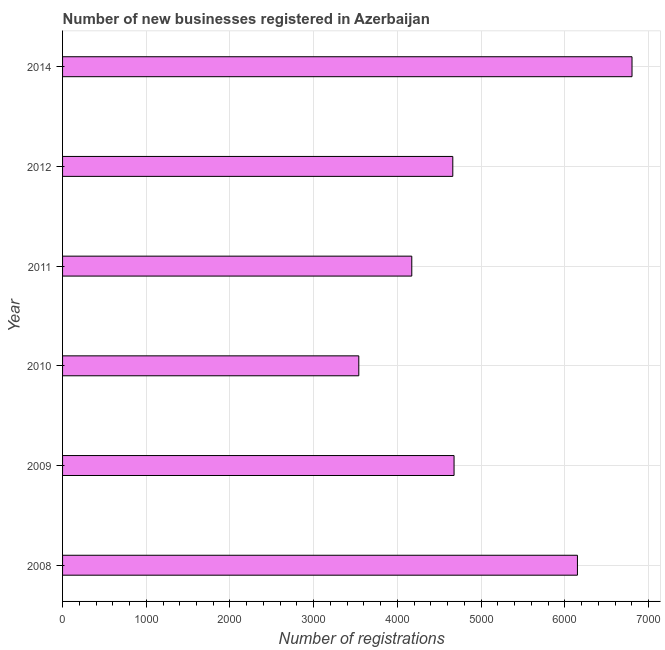Does the graph contain any zero values?
Provide a succinct answer. No. What is the title of the graph?
Keep it short and to the point. Number of new businesses registered in Azerbaijan. What is the label or title of the X-axis?
Ensure brevity in your answer.  Number of registrations. What is the number of new business registrations in 2011?
Your answer should be very brief. 4172. Across all years, what is the maximum number of new business registrations?
Keep it short and to the point. 6803. Across all years, what is the minimum number of new business registrations?
Offer a terse response. 3539. What is the sum of the number of new business registrations?
Offer a very short reply. 3.00e+04. What is the difference between the number of new business registrations in 2008 and 2014?
Provide a succinct answer. -652. What is the median number of new business registrations?
Give a very brief answer. 4669.5. In how many years, is the number of new business registrations greater than 6000 ?
Offer a very short reply. 2. Do a majority of the years between 2008 and 2012 (inclusive) have number of new business registrations greater than 4600 ?
Your answer should be very brief. Yes. What is the ratio of the number of new business registrations in 2008 to that in 2014?
Keep it short and to the point. 0.9. Is the difference between the number of new business registrations in 2009 and 2011 greater than the difference between any two years?
Offer a terse response. No. What is the difference between the highest and the second highest number of new business registrations?
Make the answer very short. 652. Is the sum of the number of new business registrations in 2011 and 2012 greater than the maximum number of new business registrations across all years?
Provide a short and direct response. Yes. What is the difference between the highest and the lowest number of new business registrations?
Your response must be concise. 3264. In how many years, is the number of new business registrations greater than the average number of new business registrations taken over all years?
Your response must be concise. 2. How many bars are there?
Give a very brief answer. 6. What is the Number of registrations in 2008?
Offer a very short reply. 6151. What is the Number of registrations in 2009?
Offer a terse response. 4677. What is the Number of registrations in 2010?
Your answer should be very brief. 3539. What is the Number of registrations in 2011?
Keep it short and to the point. 4172. What is the Number of registrations in 2012?
Your answer should be compact. 4662. What is the Number of registrations in 2014?
Provide a short and direct response. 6803. What is the difference between the Number of registrations in 2008 and 2009?
Your response must be concise. 1474. What is the difference between the Number of registrations in 2008 and 2010?
Keep it short and to the point. 2612. What is the difference between the Number of registrations in 2008 and 2011?
Your answer should be very brief. 1979. What is the difference between the Number of registrations in 2008 and 2012?
Offer a terse response. 1489. What is the difference between the Number of registrations in 2008 and 2014?
Your answer should be very brief. -652. What is the difference between the Number of registrations in 2009 and 2010?
Your answer should be compact. 1138. What is the difference between the Number of registrations in 2009 and 2011?
Provide a succinct answer. 505. What is the difference between the Number of registrations in 2009 and 2014?
Give a very brief answer. -2126. What is the difference between the Number of registrations in 2010 and 2011?
Keep it short and to the point. -633. What is the difference between the Number of registrations in 2010 and 2012?
Provide a short and direct response. -1123. What is the difference between the Number of registrations in 2010 and 2014?
Give a very brief answer. -3264. What is the difference between the Number of registrations in 2011 and 2012?
Give a very brief answer. -490. What is the difference between the Number of registrations in 2011 and 2014?
Your response must be concise. -2631. What is the difference between the Number of registrations in 2012 and 2014?
Your answer should be very brief. -2141. What is the ratio of the Number of registrations in 2008 to that in 2009?
Your answer should be very brief. 1.31. What is the ratio of the Number of registrations in 2008 to that in 2010?
Offer a terse response. 1.74. What is the ratio of the Number of registrations in 2008 to that in 2011?
Ensure brevity in your answer.  1.47. What is the ratio of the Number of registrations in 2008 to that in 2012?
Your answer should be compact. 1.32. What is the ratio of the Number of registrations in 2008 to that in 2014?
Give a very brief answer. 0.9. What is the ratio of the Number of registrations in 2009 to that in 2010?
Keep it short and to the point. 1.32. What is the ratio of the Number of registrations in 2009 to that in 2011?
Offer a very short reply. 1.12. What is the ratio of the Number of registrations in 2009 to that in 2012?
Give a very brief answer. 1. What is the ratio of the Number of registrations in 2009 to that in 2014?
Ensure brevity in your answer.  0.69. What is the ratio of the Number of registrations in 2010 to that in 2011?
Give a very brief answer. 0.85. What is the ratio of the Number of registrations in 2010 to that in 2012?
Your response must be concise. 0.76. What is the ratio of the Number of registrations in 2010 to that in 2014?
Your response must be concise. 0.52. What is the ratio of the Number of registrations in 2011 to that in 2012?
Your answer should be very brief. 0.9. What is the ratio of the Number of registrations in 2011 to that in 2014?
Your answer should be very brief. 0.61. What is the ratio of the Number of registrations in 2012 to that in 2014?
Ensure brevity in your answer.  0.69. 